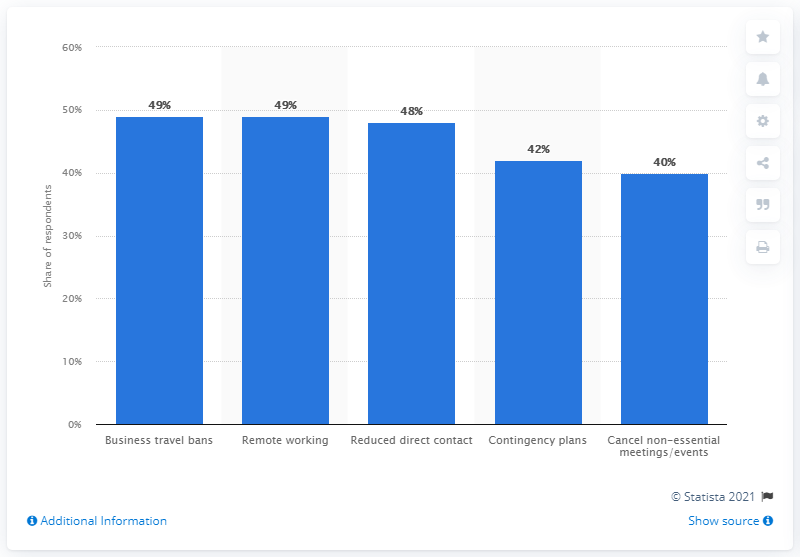Indicate a few pertinent items in this graphic. A recent survey found that 48% of Brazilians believed that employers would reduce direct contact between employees in the future. 